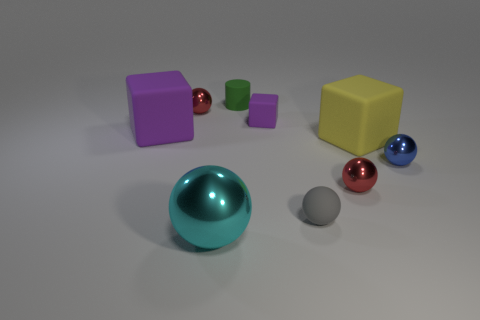Subtract all metal spheres. How many spheres are left? 1 Subtract all red blocks. How many red balls are left? 2 Subtract all spheres. How many objects are left? 4 Subtract all cyan balls. How many balls are left? 4 Subtract 1 gray spheres. How many objects are left? 8 Subtract 1 cubes. How many cubes are left? 2 Subtract all cyan cylinders. Subtract all purple cubes. How many cylinders are left? 1 Subtract all tiny purple things. Subtract all cubes. How many objects are left? 5 Add 5 cyan metal objects. How many cyan metal objects are left? 6 Add 5 small purple matte blocks. How many small purple matte blocks exist? 6 